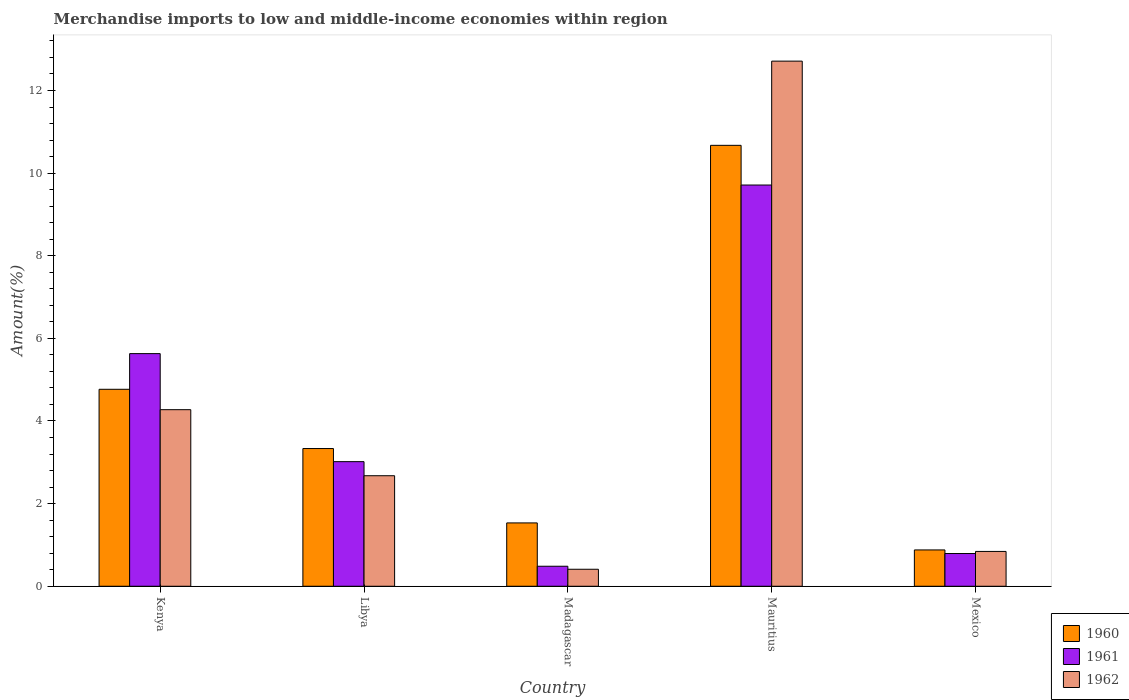How many different coloured bars are there?
Provide a succinct answer. 3. How many groups of bars are there?
Your answer should be compact. 5. How many bars are there on the 4th tick from the right?
Provide a short and direct response. 3. What is the label of the 4th group of bars from the left?
Provide a succinct answer. Mauritius. What is the percentage of amount earned from merchandise imports in 1962 in Madagascar?
Your answer should be compact. 0.41. Across all countries, what is the maximum percentage of amount earned from merchandise imports in 1960?
Your answer should be very brief. 10.67. Across all countries, what is the minimum percentage of amount earned from merchandise imports in 1960?
Your answer should be very brief. 0.88. In which country was the percentage of amount earned from merchandise imports in 1960 maximum?
Ensure brevity in your answer.  Mauritius. In which country was the percentage of amount earned from merchandise imports in 1960 minimum?
Offer a terse response. Mexico. What is the total percentage of amount earned from merchandise imports in 1961 in the graph?
Keep it short and to the point. 19.64. What is the difference between the percentage of amount earned from merchandise imports in 1962 in Libya and that in Mauritius?
Ensure brevity in your answer.  -10.04. What is the difference between the percentage of amount earned from merchandise imports in 1960 in Kenya and the percentage of amount earned from merchandise imports in 1962 in Mauritius?
Provide a succinct answer. -7.94. What is the average percentage of amount earned from merchandise imports in 1960 per country?
Your answer should be very brief. 4.24. What is the difference between the percentage of amount earned from merchandise imports of/in 1962 and percentage of amount earned from merchandise imports of/in 1961 in Mauritius?
Offer a terse response. 3. In how many countries, is the percentage of amount earned from merchandise imports in 1962 greater than 7.6 %?
Make the answer very short. 1. What is the ratio of the percentage of amount earned from merchandise imports in 1962 in Kenya to that in Madagascar?
Offer a very short reply. 10.39. Is the percentage of amount earned from merchandise imports in 1962 in Kenya less than that in Madagascar?
Give a very brief answer. No. What is the difference between the highest and the second highest percentage of amount earned from merchandise imports in 1961?
Give a very brief answer. 6.7. What is the difference between the highest and the lowest percentage of amount earned from merchandise imports in 1962?
Your response must be concise. 12.3. Is the sum of the percentage of amount earned from merchandise imports in 1961 in Madagascar and Mexico greater than the maximum percentage of amount earned from merchandise imports in 1960 across all countries?
Give a very brief answer. No. Are all the bars in the graph horizontal?
Keep it short and to the point. No. How many countries are there in the graph?
Your response must be concise. 5. What is the difference between two consecutive major ticks on the Y-axis?
Keep it short and to the point. 2. Are the values on the major ticks of Y-axis written in scientific E-notation?
Your answer should be compact. No. Does the graph contain grids?
Give a very brief answer. No. How many legend labels are there?
Ensure brevity in your answer.  3. What is the title of the graph?
Provide a short and direct response. Merchandise imports to low and middle-income economies within region. Does "1978" appear as one of the legend labels in the graph?
Provide a succinct answer. No. What is the label or title of the Y-axis?
Provide a short and direct response. Amount(%). What is the Amount(%) in 1960 in Kenya?
Offer a very short reply. 4.77. What is the Amount(%) of 1961 in Kenya?
Make the answer very short. 5.63. What is the Amount(%) of 1962 in Kenya?
Offer a terse response. 4.27. What is the Amount(%) in 1960 in Libya?
Offer a terse response. 3.33. What is the Amount(%) of 1961 in Libya?
Offer a terse response. 3.02. What is the Amount(%) of 1962 in Libya?
Ensure brevity in your answer.  2.68. What is the Amount(%) in 1960 in Madagascar?
Make the answer very short. 1.53. What is the Amount(%) of 1961 in Madagascar?
Provide a short and direct response. 0.48. What is the Amount(%) of 1962 in Madagascar?
Make the answer very short. 0.41. What is the Amount(%) of 1960 in Mauritius?
Make the answer very short. 10.67. What is the Amount(%) in 1961 in Mauritius?
Ensure brevity in your answer.  9.71. What is the Amount(%) of 1962 in Mauritius?
Your answer should be very brief. 12.71. What is the Amount(%) of 1960 in Mexico?
Ensure brevity in your answer.  0.88. What is the Amount(%) of 1961 in Mexico?
Your response must be concise. 0.79. What is the Amount(%) of 1962 in Mexico?
Give a very brief answer. 0.84. Across all countries, what is the maximum Amount(%) in 1960?
Offer a very short reply. 10.67. Across all countries, what is the maximum Amount(%) of 1961?
Your answer should be compact. 9.71. Across all countries, what is the maximum Amount(%) of 1962?
Offer a terse response. 12.71. Across all countries, what is the minimum Amount(%) of 1960?
Keep it short and to the point. 0.88. Across all countries, what is the minimum Amount(%) in 1961?
Offer a terse response. 0.48. Across all countries, what is the minimum Amount(%) in 1962?
Your response must be concise. 0.41. What is the total Amount(%) in 1960 in the graph?
Provide a succinct answer. 21.19. What is the total Amount(%) of 1961 in the graph?
Provide a short and direct response. 19.64. What is the total Amount(%) of 1962 in the graph?
Ensure brevity in your answer.  20.91. What is the difference between the Amount(%) in 1960 in Kenya and that in Libya?
Provide a short and direct response. 1.43. What is the difference between the Amount(%) of 1961 in Kenya and that in Libya?
Provide a short and direct response. 2.61. What is the difference between the Amount(%) in 1962 in Kenya and that in Libya?
Your answer should be compact. 1.6. What is the difference between the Amount(%) in 1960 in Kenya and that in Madagascar?
Make the answer very short. 3.23. What is the difference between the Amount(%) in 1961 in Kenya and that in Madagascar?
Keep it short and to the point. 5.15. What is the difference between the Amount(%) in 1962 in Kenya and that in Madagascar?
Keep it short and to the point. 3.86. What is the difference between the Amount(%) in 1960 in Kenya and that in Mauritius?
Your answer should be compact. -5.9. What is the difference between the Amount(%) in 1961 in Kenya and that in Mauritius?
Offer a very short reply. -4.08. What is the difference between the Amount(%) of 1962 in Kenya and that in Mauritius?
Give a very brief answer. -8.44. What is the difference between the Amount(%) of 1960 in Kenya and that in Mexico?
Offer a terse response. 3.89. What is the difference between the Amount(%) in 1961 in Kenya and that in Mexico?
Ensure brevity in your answer.  4.84. What is the difference between the Amount(%) of 1962 in Kenya and that in Mexico?
Offer a very short reply. 3.43. What is the difference between the Amount(%) of 1960 in Libya and that in Madagascar?
Keep it short and to the point. 1.8. What is the difference between the Amount(%) of 1961 in Libya and that in Madagascar?
Provide a succinct answer. 2.53. What is the difference between the Amount(%) in 1962 in Libya and that in Madagascar?
Keep it short and to the point. 2.26. What is the difference between the Amount(%) in 1960 in Libya and that in Mauritius?
Provide a succinct answer. -7.34. What is the difference between the Amount(%) in 1961 in Libya and that in Mauritius?
Make the answer very short. -6.7. What is the difference between the Amount(%) in 1962 in Libya and that in Mauritius?
Offer a very short reply. -10.04. What is the difference between the Amount(%) of 1960 in Libya and that in Mexico?
Your answer should be very brief. 2.45. What is the difference between the Amount(%) in 1961 in Libya and that in Mexico?
Offer a very short reply. 2.22. What is the difference between the Amount(%) in 1962 in Libya and that in Mexico?
Ensure brevity in your answer.  1.83. What is the difference between the Amount(%) of 1960 in Madagascar and that in Mauritius?
Give a very brief answer. -9.14. What is the difference between the Amount(%) in 1961 in Madagascar and that in Mauritius?
Your answer should be very brief. -9.23. What is the difference between the Amount(%) in 1962 in Madagascar and that in Mauritius?
Offer a very short reply. -12.3. What is the difference between the Amount(%) in 1960 in Madagascar and that in Mexico?
Ensure brevity in your answer.  0.65. What is the difference between the Amount(%) of 1961 in Madagascar and that in Mexico?
Provide a short and direct response. -0.31. What is the difference between the Amount(%) of 1962 in Madagascar and that in Mexico?
Your answer should be very brief. -0.43. What is the difference between the Amount(%) in 1960 in Mauritius and that in Mexico?
Your response must be concise. 9.79. What is the difference between the Amount(%) in 1961 in Mauritius and that in Mexico?
Ensure brevity in your answer.  8.92. What is the difference between the Amount(%) in 1962 in Mauritius and that in Mexico?
Provide a succinct answer. 11.87. What is the difference between the Amount(%) of 1960 in Kenya and the Amount(%) of 1961 in Libya?
Offer a terse response. 1.75. What is the difference between the Amount(%) in 1960 in Kenya and the Amount(%) in 1962 in Libya?
Offer a terse response. 2.09. What is the difference between the Amount(%) of 1961 in Kenya and the Amount(%) of 1962 in Libya?
Give a very brief answer. 2.96. What is the difference between the Amount(%) in 1960 in Kenya and the Amount(%) in 1961 in Madagascar?
Make the answer very short. 4.28. What is the difference between the Amount(%) of 1960 in Kenya and the Amount(%) of 1962 in Madagascar?
Your answer should be very brief. 4.36. What is the difference between the Amount(%) of 1961 in Kenya and the Amount(%) of 1962 in Madagascar?
Give a very brief answer. 5.22. What is the difference between the Amount(%) in 1960 in Kenya and the Amount(%) in 1961 in Mauritius?
Your response must be concise. -4.94. What is the difference between the Amount(%) of 1960 in Kenya and the Amount(%) of 1962 in Mauritius?
Provide a short and direct response. -7.94. What is the difference between the Amount(%) of 1961 in Kenya and the Amount(%) of 1962 in Mauritius?
Offer a very short reply. -7.08. What is the difference between the Amount(%) in 1960 in Kenya and the Amount(%) in 1961 in Mexico?
Keep it short and to the point. 3.98. What is the difference between the Amount(%) in 1960 in Kenya and the Amount(%) in 1962 in Mexico?
Make the answer very short. 3.92. What is the difference between the Amount(%) of 1961 in Kenya and the Amount(%) of 1962 in Mexico?
Your answer should be very brief. 4.79. What is the difference between the Amount(%) of 1960 in Libya and the Amount(%) of 1961 in Madagascar?
Provide a succinct answer. 2.85. What is the difference between the Amount(%) of 1960 in Libya and the Amount(%) of 1962 in Madagascar?
Give a very brief answer. 2.92. What is the difference between the Amount(%) of 1961 in Libya and the Amount(%) of 1962 in Madagascar?
Keep it short and to the point. 2.6. What is the difference between the Amount(%) in 1960 in Libya and the Amount(%) in 1961 in Mauritius?
Provide a short and direct response. -6.38. What is the difference between the Amount(%) in 1960 in Libya and the Amount(%) in 1962 in Mauritius?
Your answer should be very brief. -9.38. What is the difference between the Amount(%) in 1961 in Libya and the Amount(%) in 1962 in Mauritius?
Your answer should be compact. -9.69. What is the difference between the Amount(%) of 1960 in Libya and the Amount(%) of 1961 in Mexico?
Provide a short and direct response. 2.54. What is the difference between the Amount(%) of 1960 in Libya and the Amount(%) of 1962 in Mexico?
Your answer should be very brief. 2.49. What is the difference between the Amount(%) of 1961 in Libya and the Amount(%) of 1962 in Mexico?
Your response must be concise. 2.17. What is the difference between the Amount(%) in 1960 in Madagascar and the Amount(%) in 1961 in Mauritius?
Your response must be concise. -8.18. What is the difference between the Amount(%) in 1960 in Madagascar and the Amount(%) in 1962 in Mauritius?
Provide a short and direct response. -11.18. What is the difference between the Amount(%) in 1961 in Madagascar and the Amount(%) in 1962 in Mauritius?
Provide a succinct answer. -12.23. What is the difference between the Amount(%) of 1960 in Madagascar and the Amount(%) of 1961 in Mexico?
Ensure brevity in your answer.  0.74. What is the difference between the Amount(%) of 1960 in Madagascar and the Amount(%) of 1962 in Mexico?
Your answer should be compact. 0.69. What is the difference between the Amount(%) in 1961 in Madagascar and the Amount(%) in 1962 in Mexico?
Your answer should be very brief. -0.36. What is the difference between the Amount(%) in 1960 in Mauritius and the Amount(%) in 1961 in Mexico?
Give a very brief answer. 9.88. What is the difference between the Amount(%) in 1960 in Mauritius and the Amount(%) in 1962 in Mexico?
Keep it short and to the point. 9.83. What is the difference between the Amount(%) in 1961 in Mauritius and the Amount(%) in 1962 in Mexico?
Offer a terse response. 8.87. What is the average Amount(%) in 1960 per country?
Offer a terse response. 4.24. What is the average Amount(%) of 1961 per country?
Give a very brief answer. 3.93. What is the average Amount(%) in 1962 per country?
Give a very brief answer. 4.18. What is the difference between the Amount(%) of 1960 and Amount(%) of 1961 in Kenya?
Give a very brief answer. -0.86. What is the difference between the Amount(%) of 1960 and Amount(%) of 1962 in Kenya?
Your response must be concise. 0.49. What is the difference between the Amount(%) in 1961 and Amount(%) in 1962 in Kenya?
Offer a very short reply. 1.36. What is the difference between the Amount(%) of 1960 and Amount(%) of 1961 in Libya?
Provide a succinct answer. 0.32. What is the difference between the Amount(%) of 1960 and Amount(%) of 1962 in Libya?
Provide a short and direct response. 0.66. What is the difference between the Amount(%) of 1961 and Amount(%) of 1962 in Libya?
Your response must be concise. 0.34. What is the difference between the Amount(%) in 1960 and Amount(%) in 1961 in Madagascar?
Offer a very short reply. 1.05. What is the difference between the Amount(%) in 1960 and Amount(%) in 1962 in Madagascar?
Ensure brevity in your answer.  1.12. What is the difference between the Amount(%) in 1961 and Amount(%) in 1962 in Madagascar?
Offer a terse response. 0.07. What is the difference between the Amount(%) of 1960 and Amount(%) of 1961 in Mauritius?
Make the answer very short. 0.96. What is the difference between the Amount(%) of 1960 and Amount(%) of 1962 in Mauritius?
Your answer should be very brief. -2.04. What is the difference between the Amount(%) in 1961 and Amount(%) in 1962 in Mauritius?
Ensure brevity in your answer.  -3. What is the difference between the Amount(%) in 1960 and Amount(%) in 1961 in Mexico?
Offer a terse response. 0.09. What is the difference between the Amount(%) of 1960 and Amount(%) of 1962 in Mexico?
Offer a terse response. 0.04. What is the difference between the Amount(%) of 1961 and Amount(%) of 1962 in Mexico?
Provide a short and direct response. -0.05. What is the ratio of the Amount(%) of 1960 in Kenya to that in Libya?
Provide a short and direct response. 1.43. What is the ratio of the Amount(%) in 1961 in Kenya to that in Libya?
Provide a short and direct response. 1.87. What is the ratio of the Amount(%) in 1962 in Kenya to that in Libya?
Your response must be concise. 1.6. What is the ratio of the Amount(%) in 1960 in Kenya to that in Madagascar?
Your answer should be compact. 3.11. What is the ratio of the Amount(%) in 1961 in Kenya to that in Madagascar?
Your response must be concise. 11.62. What is the ratio of the Amount(%) in 1962 in Kenya to that in Madagascar?
Give a very brief answer. 10.39. What is the ratio of the Amount(%) in 1960 in Kenya to that in Mauritius?
Your response must be concise. 0.45. What is the ratio of the Amount(%) in 1961 in Kenya to that in Mauritius?
Your answer should be very brief. 0.58. What is the ratio of the Amount(%) of 1962 in Kenya to that in Mauritius?
Offer a terse response. 0.34. What is the ratio of the Amount(%) in 1960 in Kenya to that in Mexico?
Provide a short and direct response. 5.42. What is the ratio of the Amount(%) in 1961 in Kenya to that in Mexico?
Ensure brevity in your answer.  7.11. What is the ratio of the Amount(%) of 1962 in Kenya to that in Mexico?
Offer a terse response. 5.07. What is the ratio of the Amount(%) of 1960 in Libya to that in Madagascar?
Offer a very short reply. 2.17. What is the ratio of the Amount(%) of 1961 in Libya to that in Madagascar?
Your answer should be compact. 6.23. What is the ratio of the Amount(%) of 1962 in Libya to that in Madagascar?
Ensure brevity in your answer.  6.51. What is the ratio of the Amount(%) in 1960 in Libya to that in Mauritius?
Your answer should be compact. 0.31. What is the ratio of the Amount(%) in 1961 in Libya to that in Mauritius?
Ensure brevity in your answer.  0.31. What is the ratio of the Amount(%) in 1962 in Libya to that in Mauritius?
Offer a very short reply. 0.21. What is the ratio of the Amount(%) of 1960 in Libya to that in Mexico?
Your answer should be compact. 3.79. What is the ratio of the Amount(%) in 1961 in Libya to that in Mexico?
Your answer should be very brief. 3.81. What is the ratio of the Amount(%) in 1962 in Libya to that in Mexico?
Offer a very short reply. 3.17. What is the ratio of the Amount(%) of 1960 in Madagascar to that in Mauritius?
Ensure brevity in your answer.  0.14. What is the ratio of the Amount(%) in 1961 in Madagascar to that in Mauritius?
Provide a short and direct response. 0.05. What is the ratio of the Amount(%) in 1962 in Madagascar to that in Mauritius?
Offer a very short reply. 0.03. What is the ratio of the Amount(%) in 1960 in Madagascar to that in Mexico?
Ensure brevity in your answer.  1.74. What is the ratio of the Amount(%) of 1961 in Madagascar to that in Mexico?
Ensure brevity in your answer.  0.61. What is the ratio of the Amount(%) in 1962 in Madagascar to that in Mexico?
Your answer should be compact. 0.49. What is the ratio of the Amount(%) in 1960 in Mauritius to that in Mexico?
Your answer should be very brief. 12.14. What is the ratio of the Amount(%) of 1961 in Mauritius to that in Mexico?
Provide a succinct answer. 12.26. What is the ratio of the Amount(%) of 1962 in Mauritius to that in Mexico?
Your answer should be compact. 15.08. What is the difference between the highest and the second highest Amount(%) of 1960?
Give a very brief answer. 5.9. What is the difference between the highest and the second highest Amount(%) of 1961?
Ensure brevity in your answer.  4.08. What is the difference between the highest and the second highest Amount(%) of 1962?
Provide a short and direct response. 8.44. What is the difference between the highest and the lowest Amount(%) in 1960?
Your response must be concise. 9.79. What is the difference between the highest and the lowest Amount(%) of 1961?
Ensure brevity in your answer.  9.23. What is the difference between the highest and the lowest Amount(%) of 1962?
Make the answer very short. 12.3. 